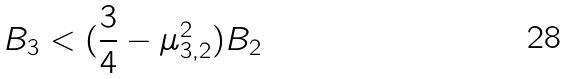<formula> <loc_0><loc_0><loc_500><loc_500>B _ { 3 } < ( \frac { 3 } { 4 } - \mu _ { 3 , 2 } ^ { 2 } ) B _ { 2 }</formula> 